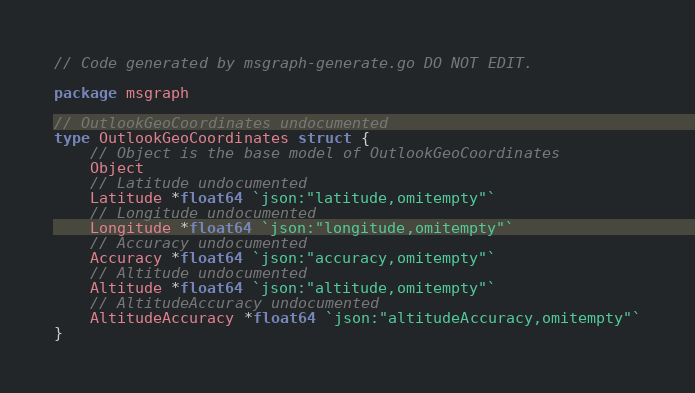Convert code to text. <code><loc_0><loc_0><loc_500><loc_500><_Go_>// Code generated by msgraph-generate.go DO NOT EDIT.

package msgraph

// OutlookGeoCoordinates undocumented
type OutlookGeoCoordinates struct {
	// Object is the base model of OutlookGeoCoordinates
	Object
	// Latitude undocumented
	Latitude *float64 `json:"latitude,omitempty"`
	// Longitude undocumented
	Longitude *float64 `json:"longitude,omitempty"`
	// Accuracy undocumented
	Accuracy *float64 `json:"accuracy,omitempty"`
	// Altitude undocumented
	Altitude *float64 `json:"altitude,omitempty"`
	// AltitudeAccuracy undocumented
	AltitudeAccuracy *float64 `json:"altitudeAccuracy,omitempty"`
}
</code> 